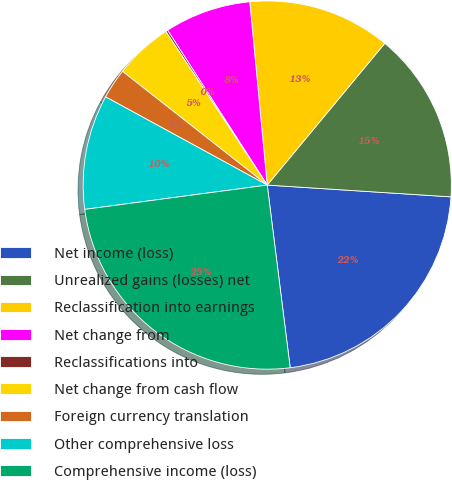Convert chart to OTSL. <chart><loc_0><loc_0><loc_500><loc_500><pie_chart><fcel>Net income (loss)<fcel>Unrealized gains (losses) net<fcel>Reclassification into earnings<fcel>Net change from<fcel>Reclassifications into<fcel>Net change from cash flow<fcel>Foreign currency translation<fcel>Other comprehensive loss<fcel>Comprehensive income (loss)<nl><fcel>21.99%<fcel>15.0%<fcel>12.53%<fcel>7.59%<fcel>0.18%<fcel>5.12%<fcel>2.65%<fcel>10.06%<fcel>24.88%<nl></chart> 